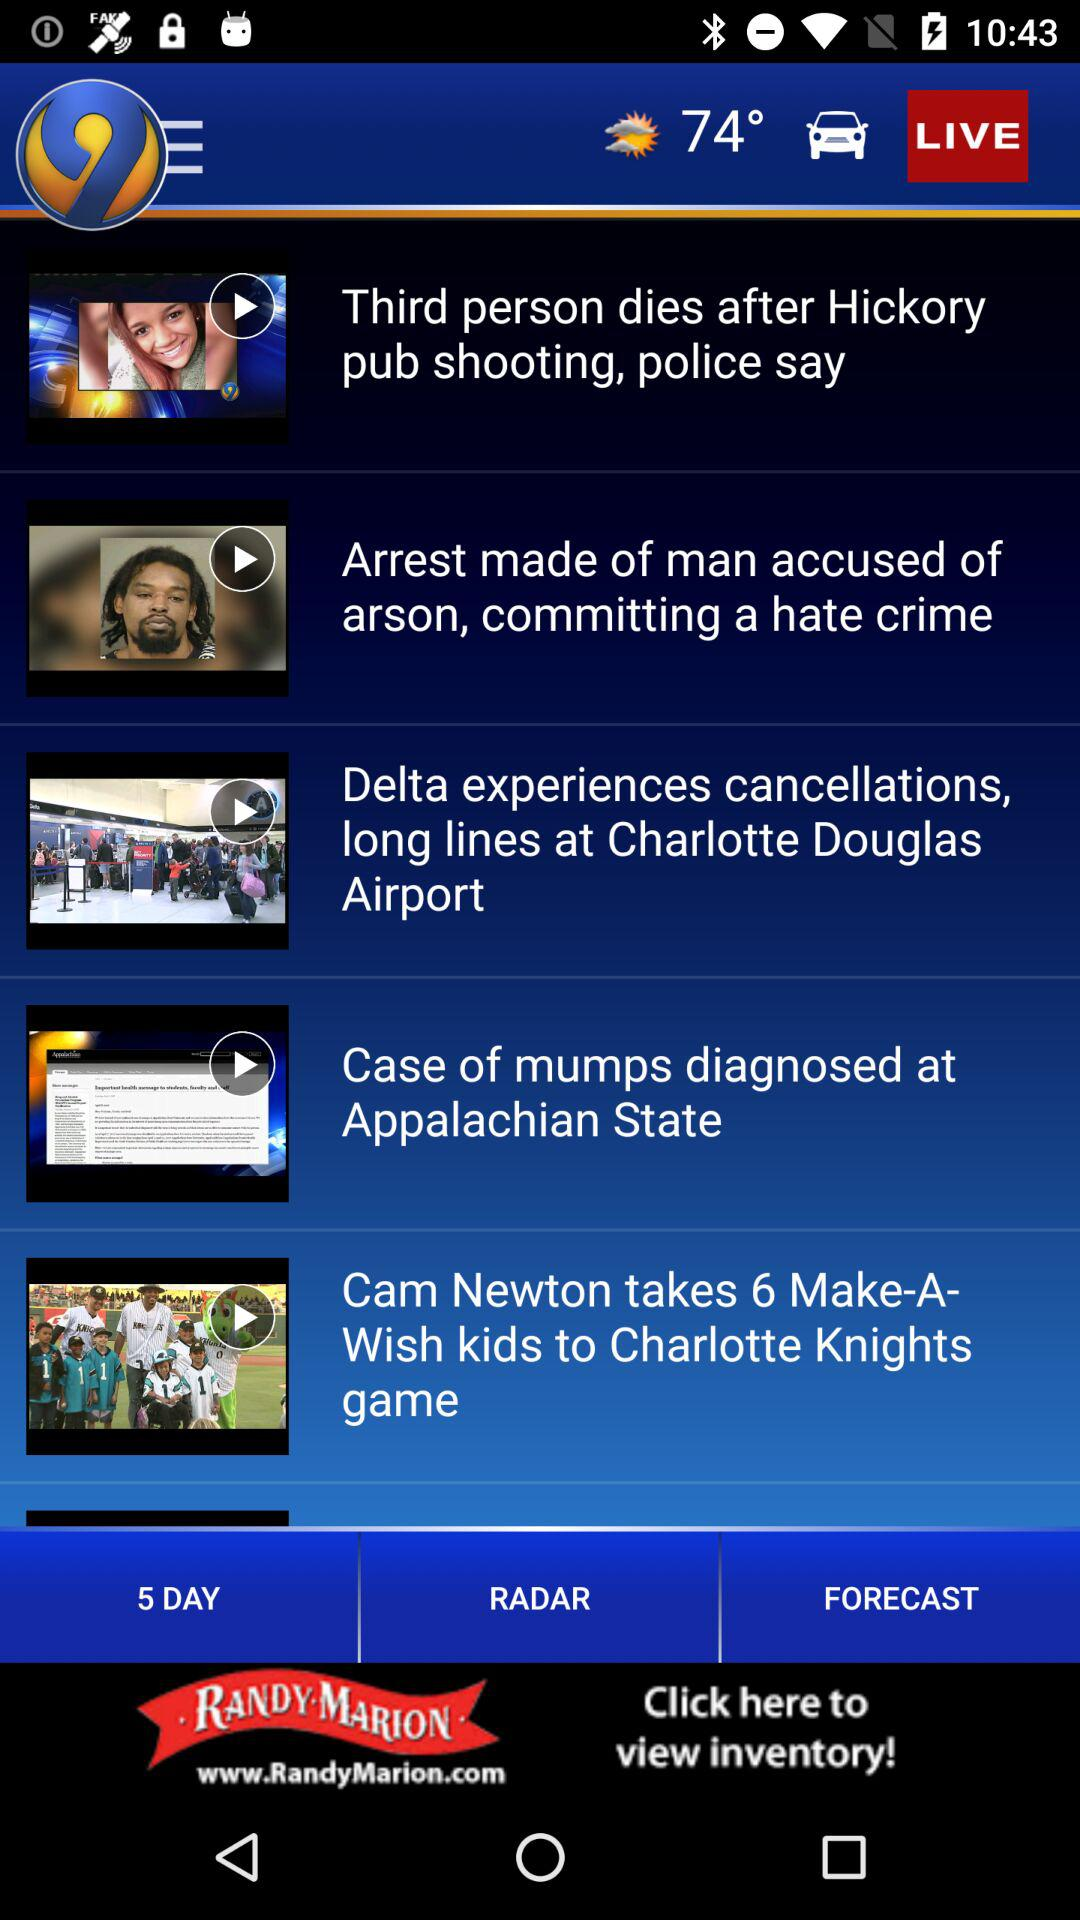How is the weather? The weather is partly sunny. 